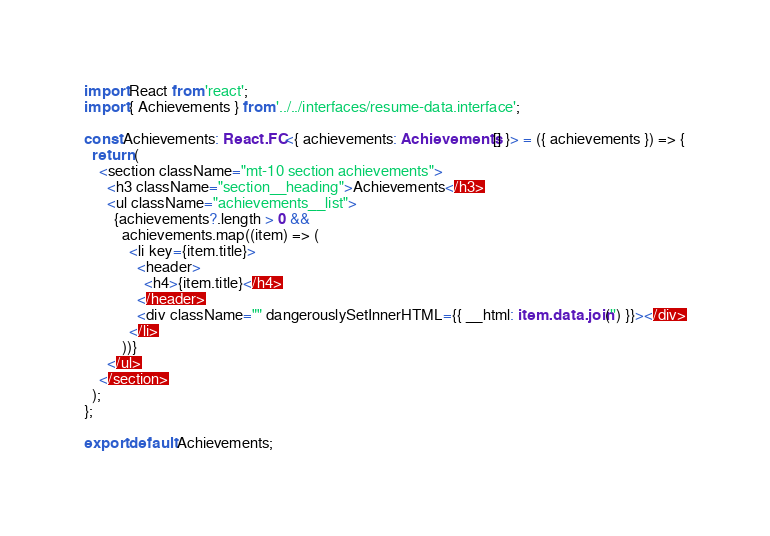Convert code to text. <code><loc_0><loc_0><loc_500><loc_500><_TypeScript_>import React from 'react';
import { Achievements } from '../../interfaces/resume-data.interface';

const Achievements: React.FC<{ achievements: Achievements[] }> = ({ achievements }) => {
  return (
    <section className="mt-10 section achievements">
      <h3 className="section__heading">Achievements</h3>
      <ul className="achievements__list">
        {achievements?.length > 0 &&
          achievements.map((item) => (
            <li key={item.title}>
              <header>
                <h4>{item.title}</h4>
              </header>
              <div className="" dangerouslySetInnerHTML={{ __html: item.data.join('') }}></div>
            </li>
          ))}
      </ul>
    </section>
  );
};

export default Achievements;
</code> 